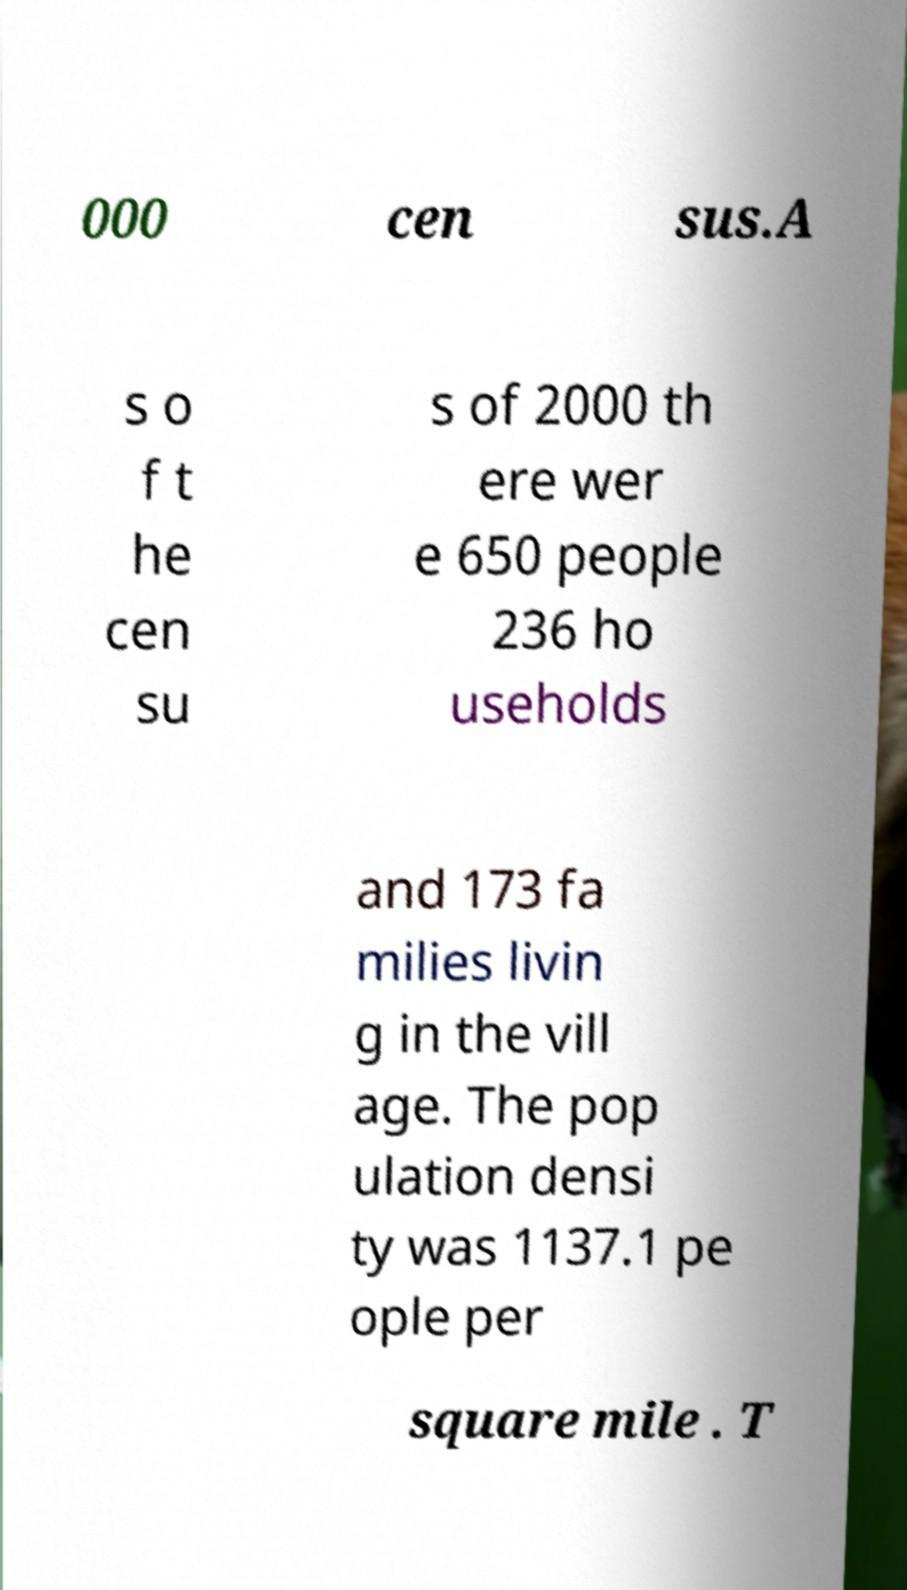Can you read and provide the text displayed in the image?This photo seems to have some interesting text. Can you extract and type it out for me? 000 cen sus.A s o f t he cen su s of 2000 th ere wer e 650 people 236 ho useholds and 173 fa milies livin g in the vill age. The pop ulation densi ty was 1137.1 pe ople per square mile . T 